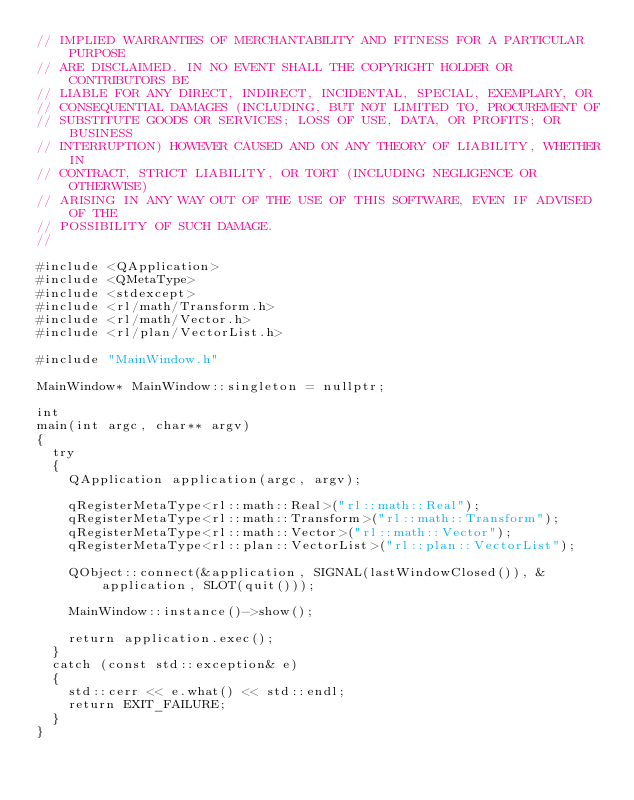<code> <loc_0><loc_0><loc_500><loc_500><_C++_>// IMPLIED WARRANTIES OF MERCHANTABILITY AND FITNESS FOR A PARTICULAR PURPOSE
// ARE DISCLAIMED. IN NO EVENT SHALL THE COPYRIGHT HOLDER OR CONTRIBUTORS BE
// LIABLE FOR ANY DIRECT, INDIRECT, INCIDENTAL, SPECIAL, EXEMPLARY, OR
// CONSEQUENTIAL DAMAGES (INCLUDING, BUT NOT LIMITED TO, PROCUREMENT OF
// SUBSTITUTE GOODS OR SERVICES; LOSS OF USE, DATA, OR PROFITS; OR BUSINESS
// INTERRUPTION) HOWEVER CAUSED AND ON ANY THEORY OF LIABILITY, WHETHER IN
// CONTRACT, STRICT LIABILITY, OR TORT (INCLUDING NEGLIGENCE OR OTHERWISE)
// ARISING IN ANY WAY OUT OF THE USE OF THIS SOFTWARE, EVEN IF ADVISED OF THE
// POSSIBILITY OF SUCH DAMAGE.
//

#include <QApplication>
#include <QMetaType>
#include <stdexcept>
#include <rl/math/Transform.h>
#include <rl/math/Vector.h>
#include <rl/plan/VectorList.h>

#include "MainWindow.h"

MainWindow* MainWindow::singleton = nullptr;

int
main(int argc, char** argv)
{
	try
	{
		QApplication application(argc, argv);
		
		qRegisterMetaType<rl::math::Real>("rl::math::Real");
		qRegisterMetaType<rl::math::Transform>("rl::math::Transform");
		qRegisterMetaType<rl::math::Vector>("rl::math::Vector");
		qRegisterMetaType<rl::plan::VectorList>("rl::plan::VectorList");
		
		QObject::connect(&application, SIGNAL(lastWindowClosed()), &application, SLOT(quit()));
		
		MainWindow::instance()->show();
		
		return application.exec();
	}
	catch (const std::exception& e)
	{
		std::cerr << e.what() << std::endl;
		return EXIT_FAILURE;
	}
}
</code> 